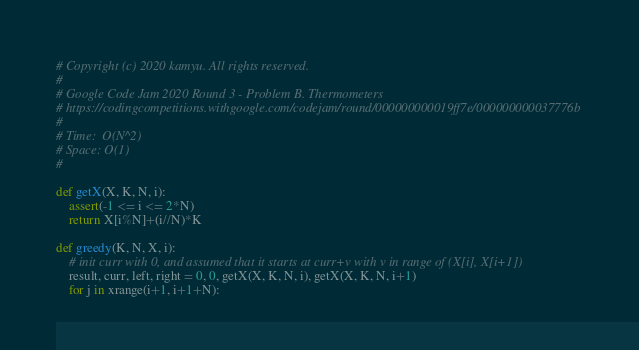<code> <loc_0><loc_0><loc_500><loc_500><_Python_># Copyright (c) 2020 kamyu. All rights reserved.
#
# Google Code Jam 2020 Round 3 - Problem B. Thermometers
# https://codingcompetitions.withgoogle.com/codejam/round/000000000019ff7e/000000000037776b
#
# Time:  O(N^2)
# Space: O(1)
#

def getX(X, K, N, i):
    assert(-1 <= i <= 2*N)
    return X[i%N]+(i//N)*K

def greedy(K, N, X, i):
    # init curr with 0, and assumed that it starts at curr+v with v in range of (X[i], X[i+1])
    result, curr, left, right = 0, 0, getX(X, K, N, i), getX(X, K, N, i+1)
    for j in xrange(i+1, i+1+N):</code> 